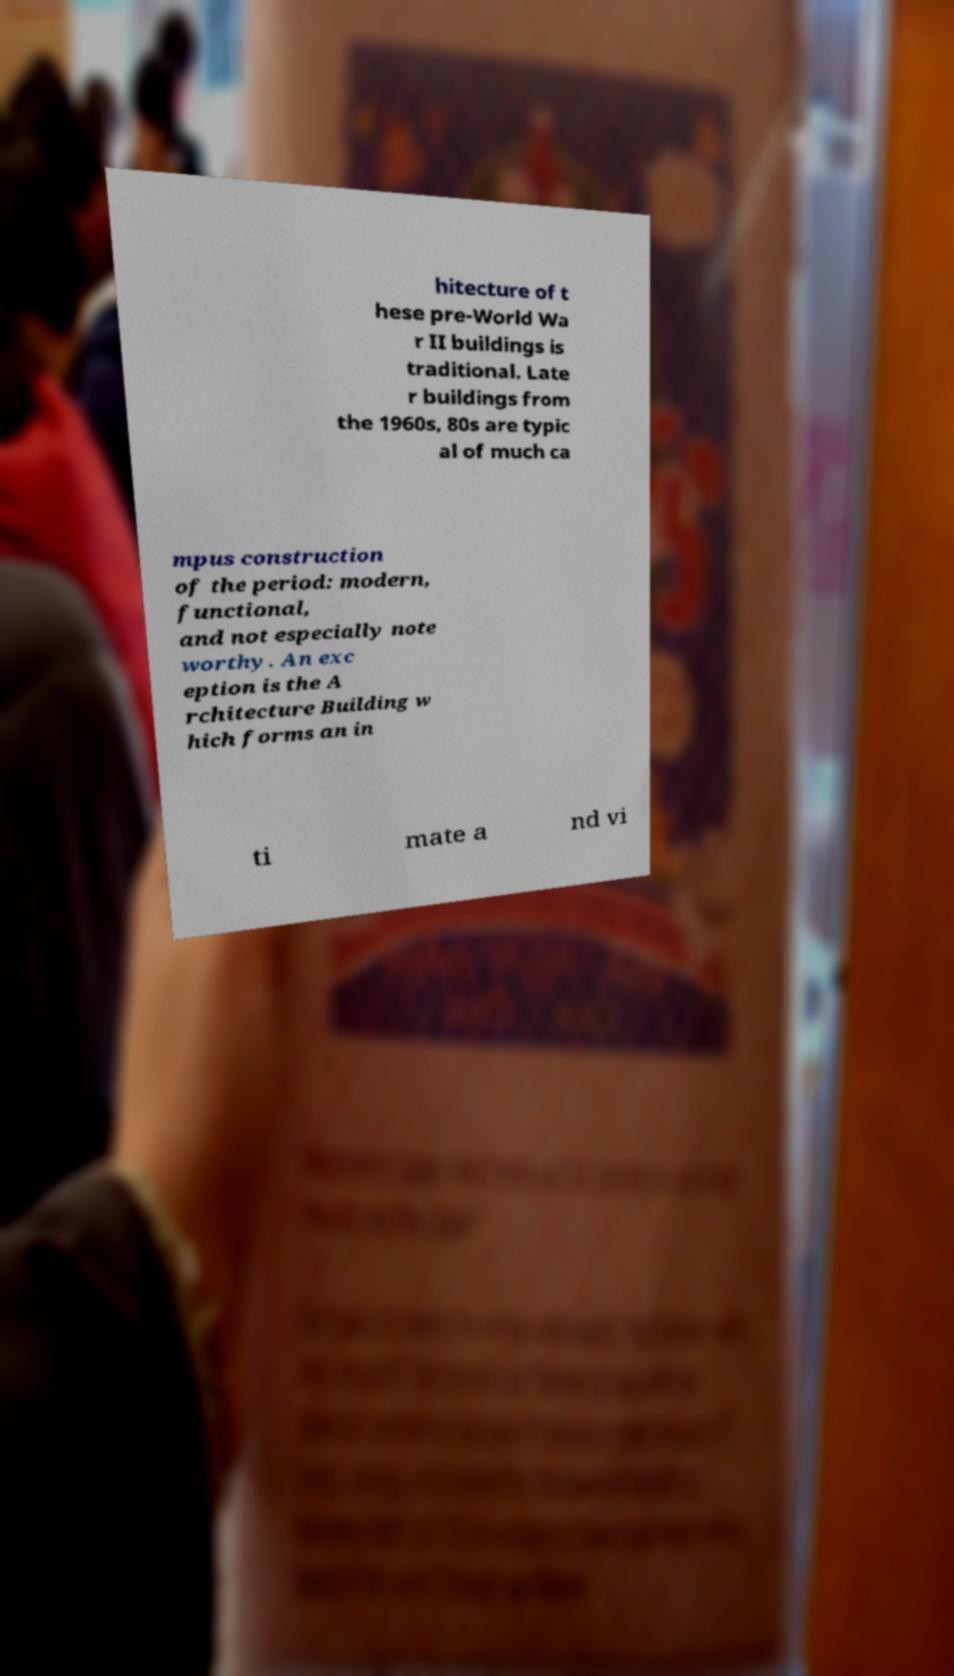Could you assist in decoding the text presented in this image and type it out clearly? hitecture of t hese pre-World Wa r II buildings is traditional. Late r buildings from the 1960s, 80s are typic al of much ca mpus construction of the period: modern, functional, and not especially note worthy. An exc eption is the A rchitecture Building w hich forms an in ti mate a nd vi 